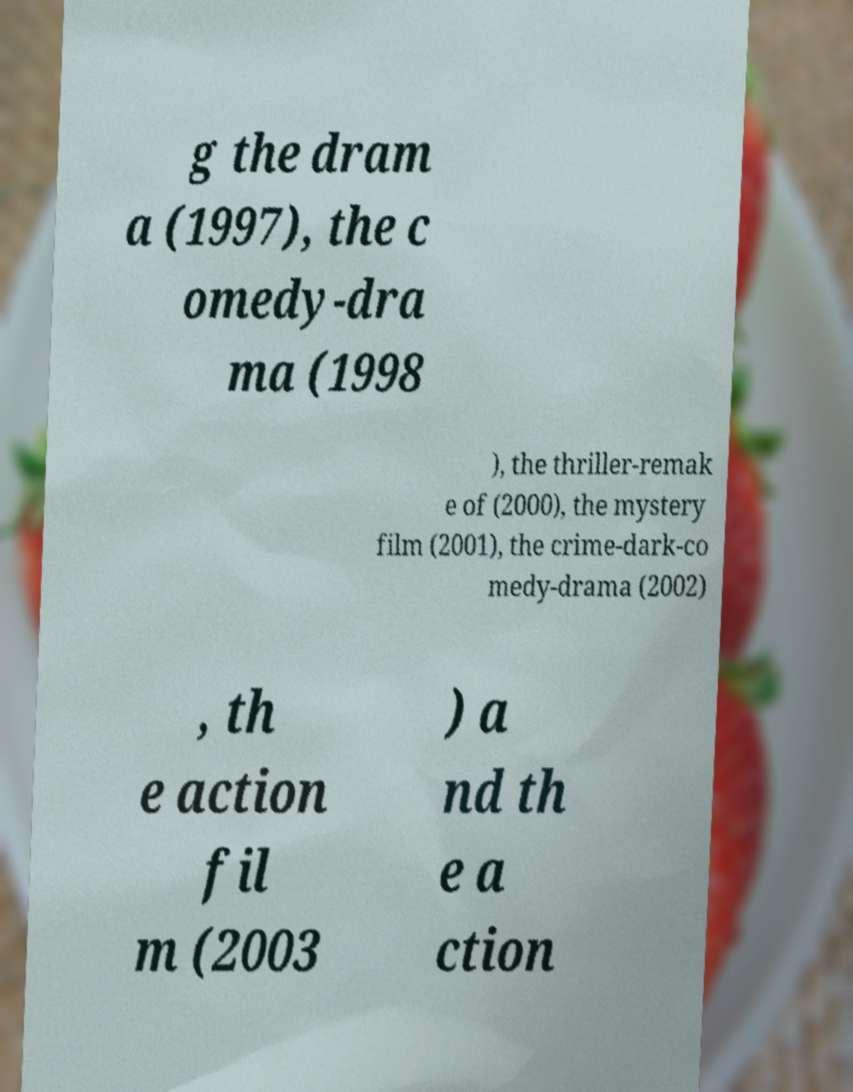I need the written content from this picture converted into text. Can you do that? g the dram a (1997), the c omedy-dra ma (1998 ), the thriller-remak e of (2000), the mystery film (2001), the crime-dark-co medy-drama (2002) , th e action fil m (2003 ) a nd th e a ction 